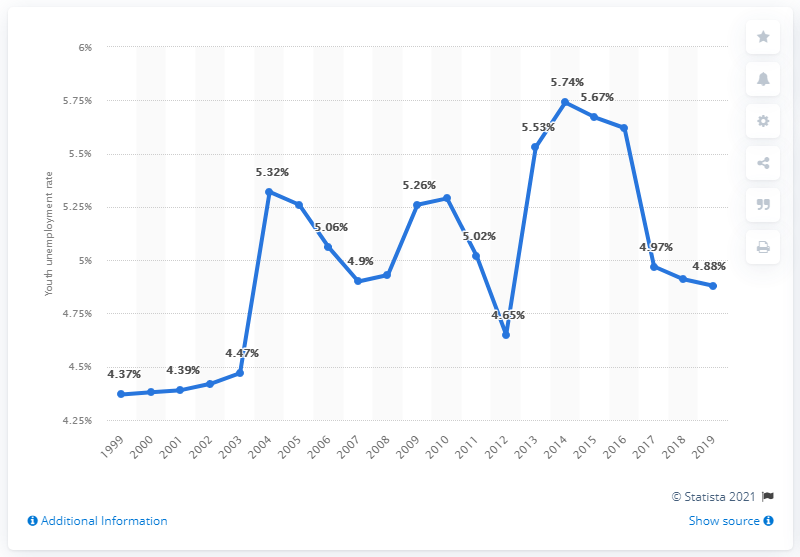What additional information can be deducted from the image regarding employment trends in Guatemala? The image also hints at the broader economic trends affecting Guatemala's labor market. For example, the peak in 2017 could indicate economic events that negatively impacted employment rates, whereas the following decline might suggest a recovery phase or adaptation by the job market. The years with lower unemployment rates might correlate with favorable economic policies, increased job creation or greater integration of youth into various sectors. 